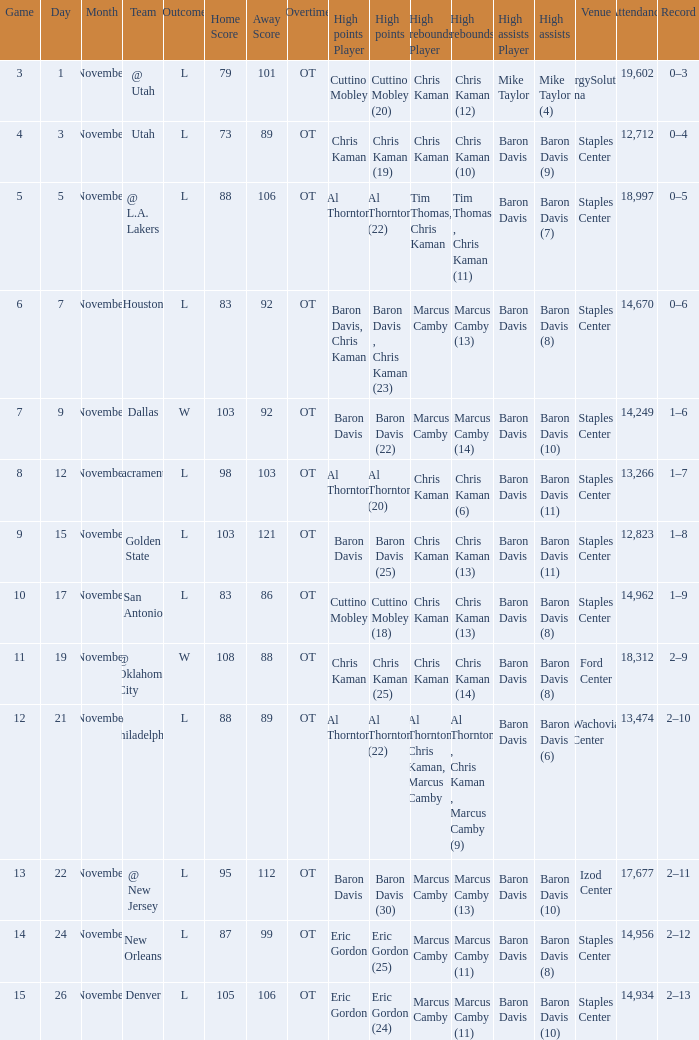Name the high points for the date of november 24 Eric Gordon (25). Can you give me this table as a dict? {'header': ['Game', 'Day', 'Month', 'Team', 'Outcome', 'Home Score', 'Away Score', 'Overtime', 'High points Player', 'High points', 'High rebounds Player', 'High rebounds', 'High assists Player', 'High assists', 'Venue', 'Attendance', 'Record'], 'rows': [['3', '1', 'November', '@ Utah', 'L', '79', '101', 'OT', 'Cuttino Mobley', 'Cuttino Mobley (20)', 'Chris Kaman', 'Chris Kaman (12)', 'Mike Taylor', 'Mike Taylor (4)', 'EnergySolutions Arena', '19,602', '0–3'], ['4', '3', 'November', 'Utah', 'L', '73', '89', 'OT', 'Chris Kaman', 'Chris Kaman (19)', 'Chris Kaman', 'Chris Kaman (10)', 'Baron Davis', 'Baron Davis (9)', 'Staples Center', '12,712', '0–4'], ['5', '5', 'November', '@ L.A. Lakers', 'L', '88', '106', 'OT', 'Al Thornton', 'Al Thornton (22)', 'Tim Thomas, Chris Kaman', 'Tim Thomas , Chris Kaman (11)', 'Baron Davis', 'Baron Davis (7)', 'Staples Center', '18,997', '0–5'], ['6', '7', 'November', 'Houston', 'L', '83', '92', 'OT', 'Baron Davis, Chris Kaman', 'Baron Davis , Chris Kaman (23)', 'Marcus Camby', 'Marcus Camby (13)', 'Baron Davis', 'Baron Davis (8)', 'Staples Center', '14,670', '0–6'], ['7', '9', 'November', 'Dallas', 'W', '103', '92', 'OT', 'Baron Davis', 'Baron Davis (22)', 'Marcus Camby', 'Marcus Camby (14)', 'Baron Davis', 'Baron Davis (10)', 'Staples Center', '14,249', '1–6'], ['8', '12', 'November', 'Sacramento', 'L', '98', '103', 'OT', 'Al Thornton', 'Al Thornton (20)', 'Chris Kaman', 'Chris Kaman (6)', 'Baron Davis', 'Baron Davis (11)', 'Staples Center', '13,266', '1–7'], ['9', '15', 'November', 'Golden State', 'L', '103', '121', 'OT', 'Baron Davis', 'Baron Davis (25)', 'Chris Kaman', 'Chris Kaman (13)', 'Baron Davis', 'Baron Davis (11)', 'Staples Center', '12,823', '1–8'], ['10', '17', 'November', 'San Antonio', 'L', '83', '86', 'OT', 'Cuttino Mobley', 'Cuttino Mobley (18)', 'Chris Kaman', 'Chris Kaman (13)', 'Baron Davis', 'Baron Davis (8)', 'Staples Center', '14,962', '1–9'], ['11', '19', 'November', '@ Oklahoma City', 'W', '108', '88', 'OT', 'Chris Kaman', 'Chris Kaman (25)', 'Chris Kaman', 'Chris Kaman (14)', 'Baron Davis', 'Baron Davis (8)', 'Ford Center', '18,312', '2–9'], ['12', '21', 'November', '@ Philadelphia', 'L', '88', '89', 'OT', 'Al Thornton', 'Al Thornton (22)', 'Al Thornton, Chris Kaman, Marcus Camby', 'Al Thornton , Chris Kaman , Marcus Camby (9)', 'Baron Davis', 'Baron Davis (6)', 'Wachovia Center', '13,474', '2–10'], ['13', '22', 'November', '@ New Jersey', 'L', '95', '112', 'OT', 'Baron Davis', 'Baron Davis (30)', 'Marcus Camby', 'Marcus Camby (13)', 'Baron Davis', 'Baron Davis (10)', 'Izod Center', '17,677', '2–11'], ['14', '24', 'November', 'New Orleans', 'L', '87', '99', 'OT', 'Eric Gordon', 'Eric Gordon (25)', 'Marcus Camby', 'Marcus Camby (11)', 'Baron Davis', 'Baron Davis (8)', 'Staples Center', '14,956', '2–12'], ['15', '26', 'November', 'Denver', 'L', '105', '106', 'OT', 'Eric Gordon', 'Eric Gordon (24)', 'Marcus Camby', 'Marcus Camby (11)', 'Baron Davis', 'Baron Davis (10)', 'Staples Center', '14,934', '2–13']]} 